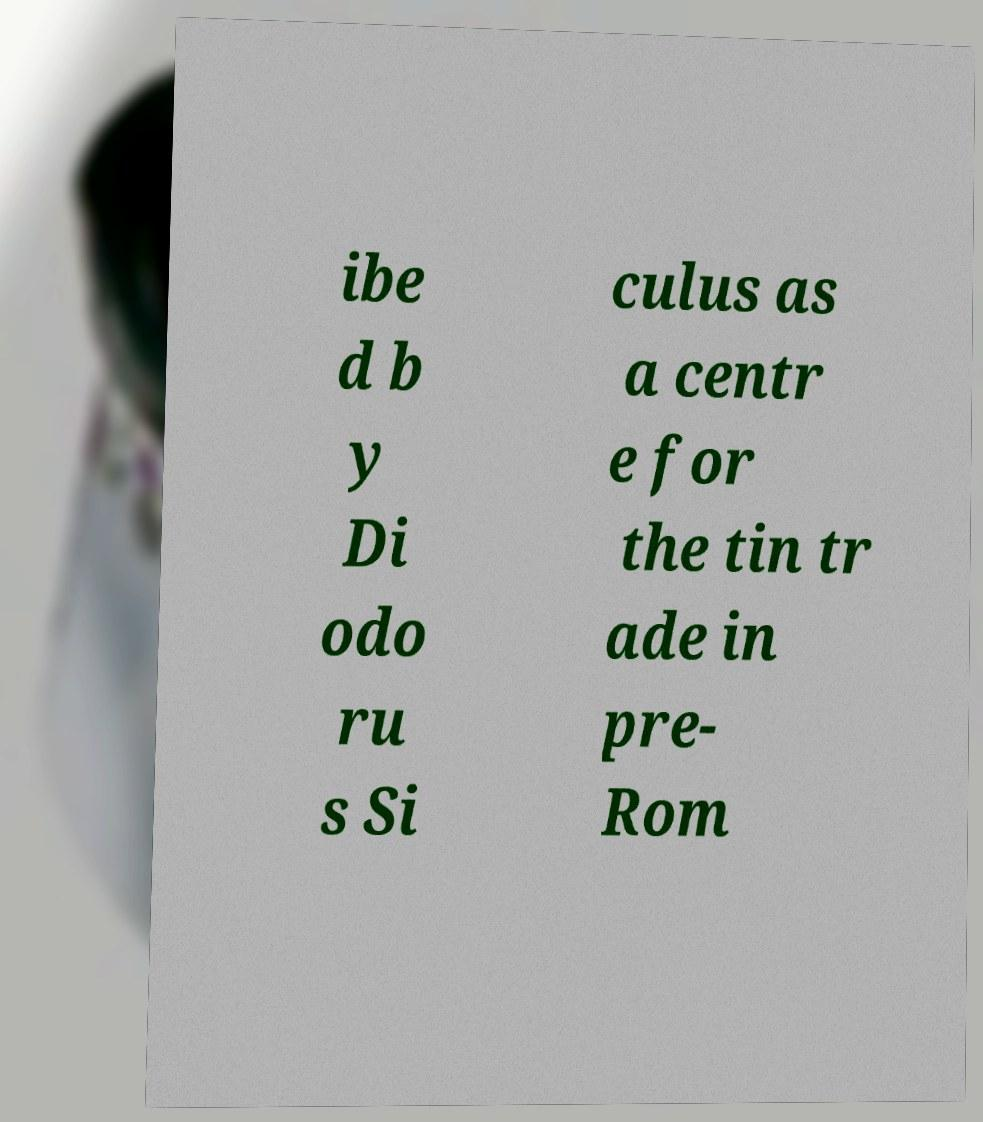Can you accurately transcribe the text from the provided image for me? ibe d b y Di odo ru s Si culus as a centr e for the tin tr ade in pre- Rom 